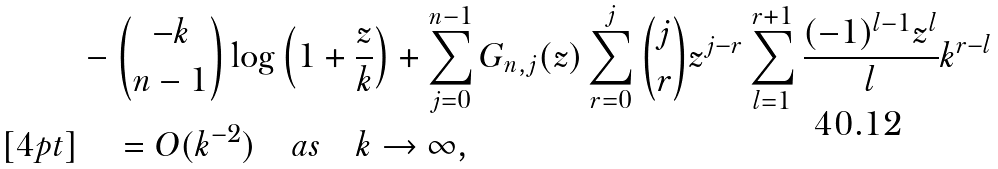<formula> <loc_0><loc_0><loc_500><loc_500>& - \binom { - k } { n - 1 } \log \left ( 1 + \frac { z } { k } \right ) + \sum _ { j = 0 } ^ { n - 1 } G _ { n , j } ( z ) \sum _ { r = 0 } ^ { j } \binom { j } { r } z ^ { j - r } \sum _ { l = 1 } ^ { r + 1 } \frac { ( - 1 ) ^ { l - 1 } z ^ { l } } { l } k ^ { r - l } \\ [ 4 p t ] & \quad = O ( k ^ { - 2 } ) \quad a s \quad k \to \infty ,</formula> 